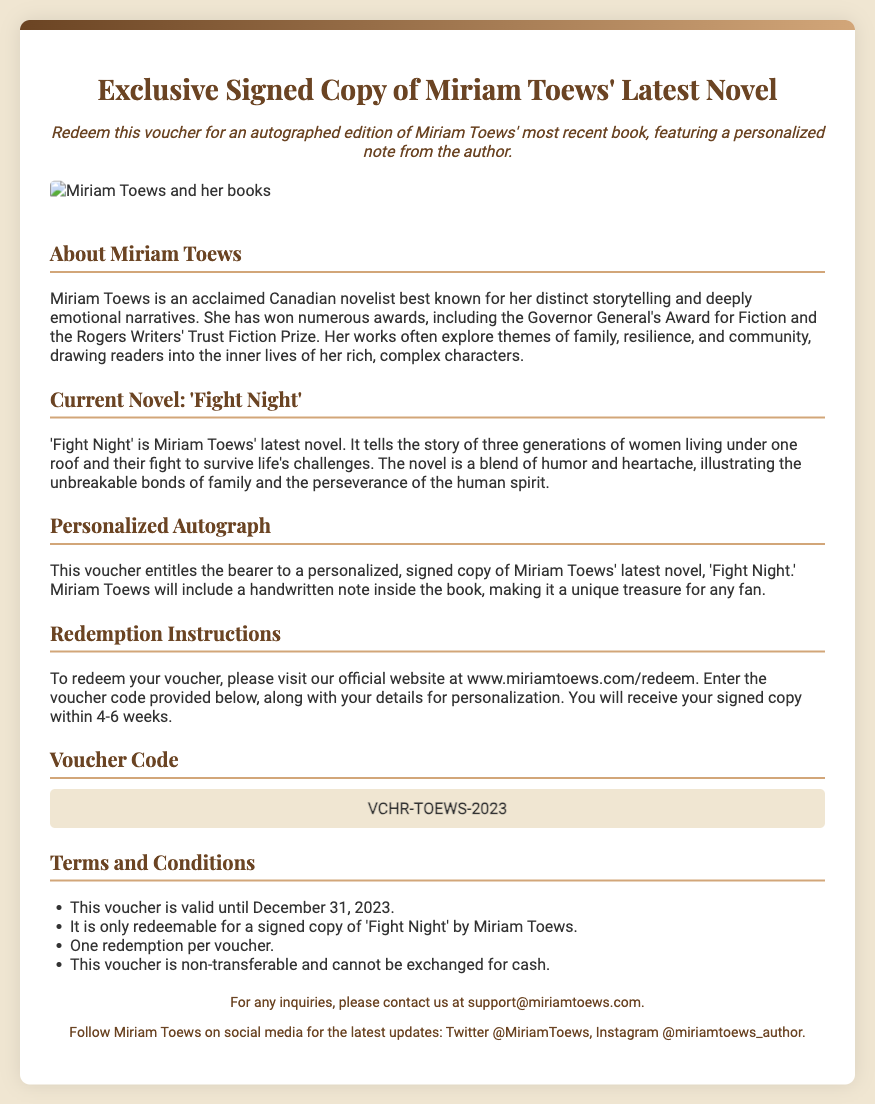What is the title of the latest novel by Miriam Toews? The title of the latest novel is mentioned in the document under the section "Current Novel," which states it is 'Fight Night.'
Answer: 'Fight Night' What is Miriam Toews known for? The document describes Miriam Toews as an acclaimed Canadian novelist known for her distinct storytelling and deeply emotional narratives.
Answer: Distinct storytelling What is the voucher code? The voucher code is listed in the "Voucher Code" section of the document.
Answer: VCHR-TOEWS-2023 Until when is the voucher valid? The validity date is specified in the "Terms and Conditions" section, stating it is valid until December 31, 2023.
Answer: December 31, 2023 What will Miriam Toews include with the signed copy? The document specifies that a personalized, handwritten note will be included with the signed copy of 'Fight Night.'
Answer: Handwritten note How many weeks will it take to receive the signed copy? The document mentions that the signed copy will be sent within 4-6 weeks of redemption.
Answer: 4-6 weeks What can this voucher not be exchanged for? The "Terms and Conditions" indicate that the voucher is non-transferable and cannot be exchanged for cash.
Answer: Cash What is required to redeem the voucher? The document provides instructions that state the voucher must be redeemed through the official website and requires entering the voucher code and personal details.
Answer: Official website 